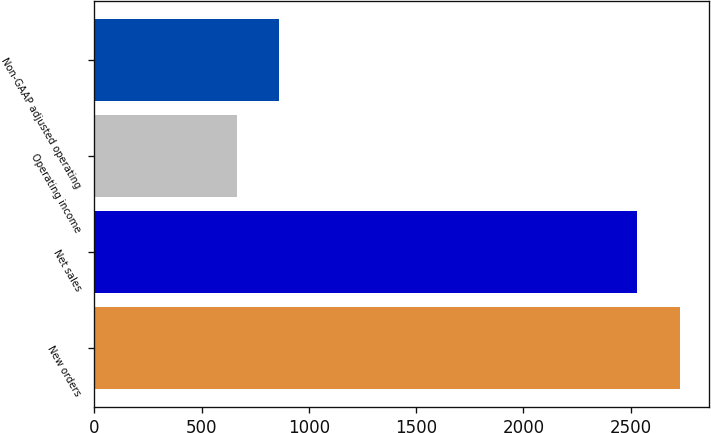Convert chart to OTSL. <chart><loc_0><loc_0><loc_500><loc_500><bar_chart><fcel>New orders<fcel>Net sales<fcel>Operating income<fcel>Non-GAAP adjusted operating<nl><fcel>2729.9<fcel>2531<fcel>664<fcel>862.9<nl></chart> 